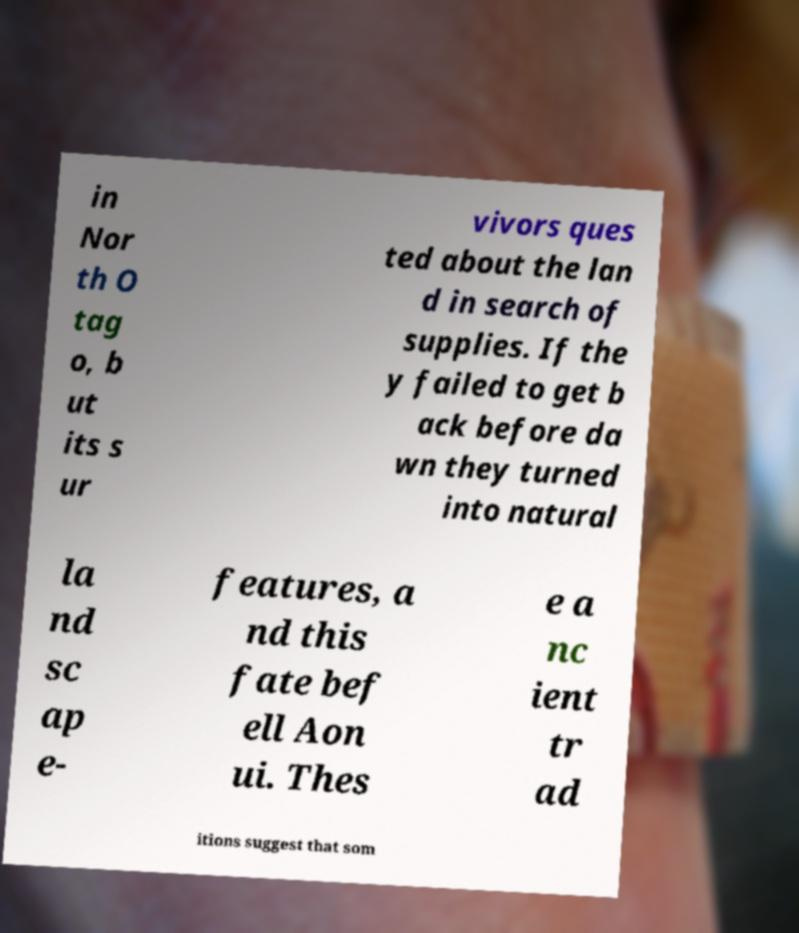I need the written content from this picture converted into text. Can you do that? in Nor th O tag o, b ut its s ur vivors ques ted about the lan d in search of supplies. If the y failed to get b ack before da wn they turned into natural la nd sc ap e- features, a nd this fate bef ell Aon ui. Thes e a nc ient tr ad itions suggest that som 